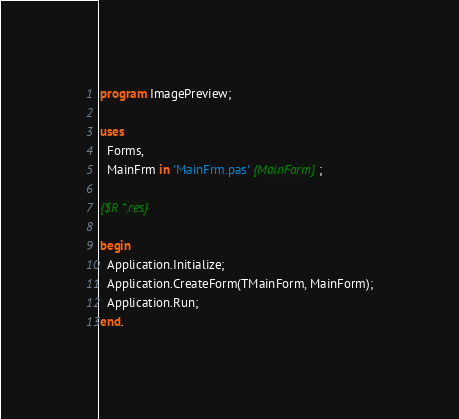<code> <loc_0><loc_0><loc_500><loc_500><_Pascal_>program ImagePreview;

uses
  Forms,
  MainFrm in 'MainFrm.pas' {MainForm};

{$R *.res}

begin
  Application.Initialize;
  Application.CreateForm(TMainForm, MainForm);
  Application.Run;
end.
</code> 